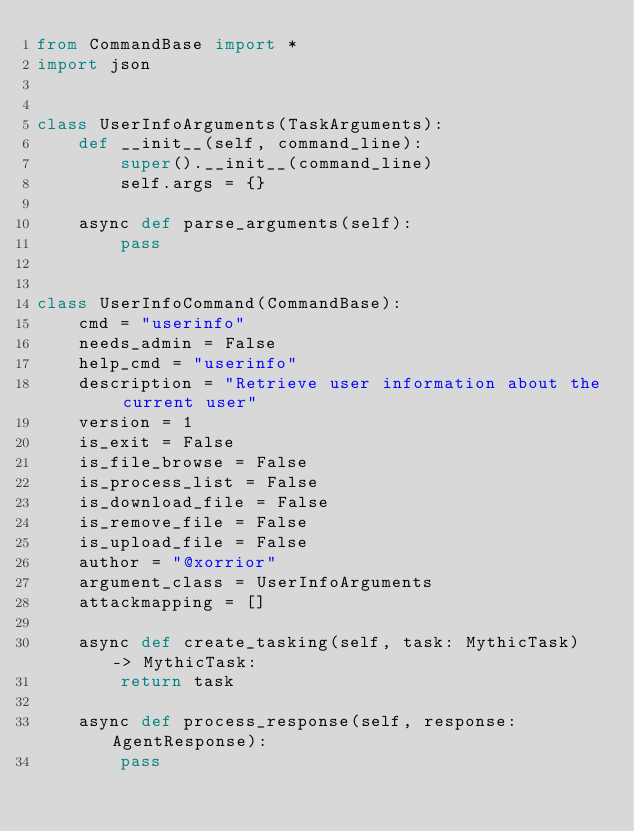<code> <loc_0><loc_0><loc_500><loc_500><_Python_>from CommandBase import *
import json


class UserInfoArguments(TaskArguments):
    def __init__(self, command_line):
        super().__init__(command_line)
        self.args = {}

    async def parse_arguments(self):
        pass


class UserInfoCommand(CommandBase):
    cmd = "userinfo"
    needs_admin = False
    help_cmd = "userinfo"
    description = "Retrieve user information about the current user"
    version = 1
    is_exit = False
    is_file_browse = False
    is_process_list = False
    is_download_file = False
    is_remove_file = False
    is_upload_file = False
    author = "@xorrior"
    argument_class = UserInfoArguments
    attackmapping = []

    async def create_tasking(self, task: MythicTask) -> MythicTask:
        return task

    async def process_response(self, response: AgentResponse):
        pass
</code> 